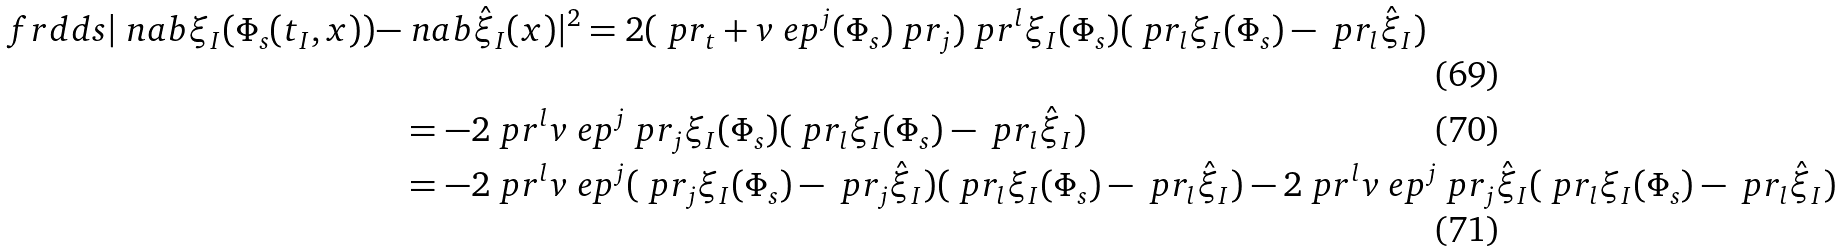<formula> <loc_0><loc_0><loc_500><loc_500>\ f r { d } { d s } | \ n a b \xi _ { I } ( \Phi _ { s } ( t _ { I } , x ) ) - & \ n a b { \hat { \xi } _ { I } } ( x ) | ^ { 2 } = 2 ( \ p r _ { t } + v _ { \ } e p ^ { j } ( \Phi _ { s } ) \ p r _ { j } ) \ p r ^ { l } \xi _ { I } ( \Phi _ { s } ) ( \ p r _ { l } \xi _ { I } ( \Phi _ { s } ) - \ p r _ { l } { \hat { \xi } } _ { I } ) \\ & = - 2 \ p r ^ { l } v _ { \ } e p ^ { j } \ p r _ { j } \xi _ { I } ( \Phi _ { s } ) ( \ p r _ { l } \xi _ { I } ( \Phi _ { s } ) - \ p r _ { l } { \hat { \xi } } _ { I } ) \\ & = - 2 \ p r ^ { l } v _ { \ } e p ^ { j } ( \ p r _ { j } \xi _ { I } ( \Phi _ { s } ) - \ p r _ { j } { \hat { \xi } } _ { I } ) ( \ p r _ { l } \xi _ { I } ( \Phi _ { s } ) - \ p r _ { l } { \hat { \xi } } _ { I } ) - 2 \ p r ^ { l } v _ { \ } e p ^ { j } \ p r _ { j } { \hat { \xi } } _ { I } ( \ p r _ { l } \xi _ { I } ( \Phi _ { s } ) - \ p r _ { l } { \hat { \xi } } _ { I } )</formula> 